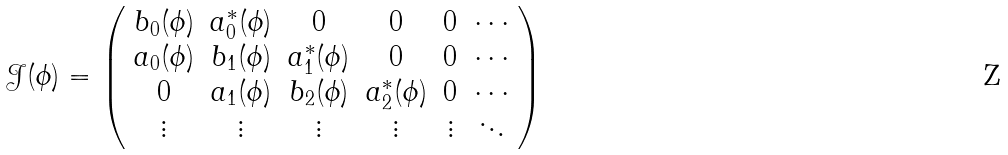<formula> <loc_0><loc_0><loc_500><loc_500>\mathcal { J } ( \phi ) = \left ( \begin{array} { c c c c c c } b _ { 0 } ( \phi ) & a _ { 0 } ^ { * } ( \phi ) & 0 & 0 & 0 & \cdots \\ a _ { 0 } ( \phi ) & b _ { 1 } ( \phi ) & a _ { 1 } ^ { * } ( \phi ) & 0 & 0 & \cdots \\ 0 & a _ { 1 } ( \phi ) & b _ { 2 } ( \phi ) & a _ { 2 } ^ { * } ( \phi ) & 0 & \cdots \\ \vdots & \vdots & \vdots & \vdots & \vdots & \ddots \end{array} \right )</formula> 